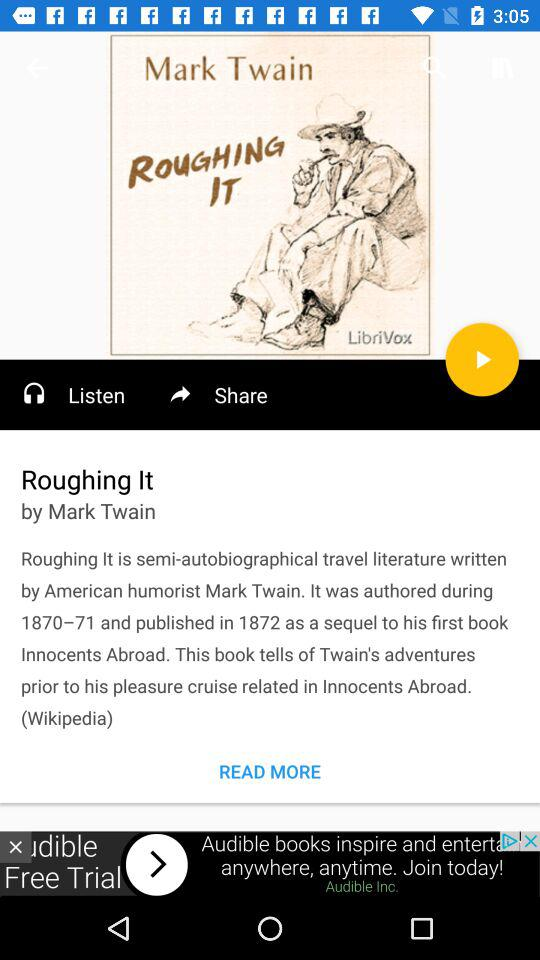Who is the author of "Roughing It"? The author is "Mark Twain". 